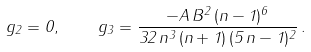<formula> <loc_0><loc_0><loc_500><loc_500>g _ { 2 } = 0 , \quad g _ { 3 } = \frac { - A \, B ^ { 2 } \, ( n - 1 ) ^ { 6 } } { 3 2 \, n ^ { 3 } \, ( n + 1 ) \, ( 5 \, n - 1 ) ^ { 2 } } \, .</formula> 